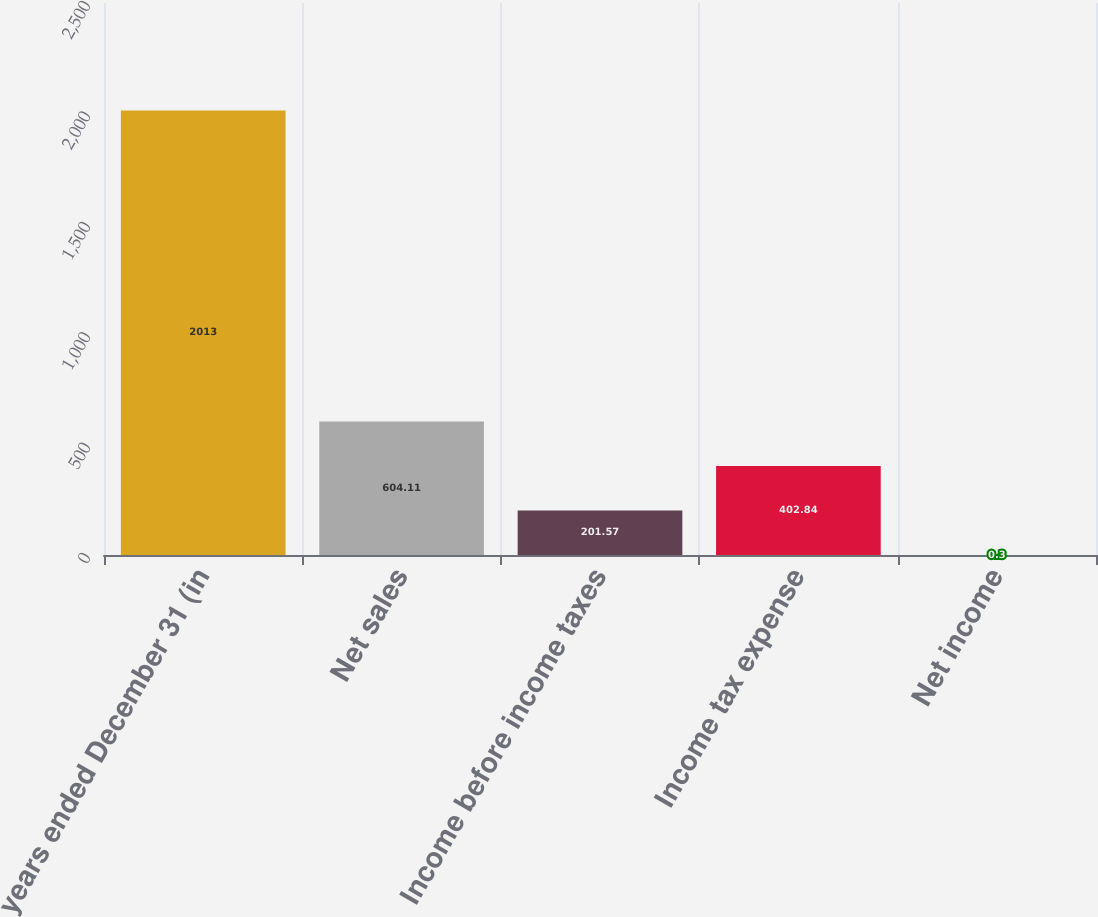Convert chart. <chart><loc_0><loc_0><loc_500><loc_500><bar_chart><fcel>years ended December 31 (in<fcel>Net sales<fcel>Income before income taxes<fcel>Income tax expense<fcel>Net income<nl><fcel>2013<fcel>604.11<fcel>201.57<fcel>402.84<fcel>0.3<nl></chart> 